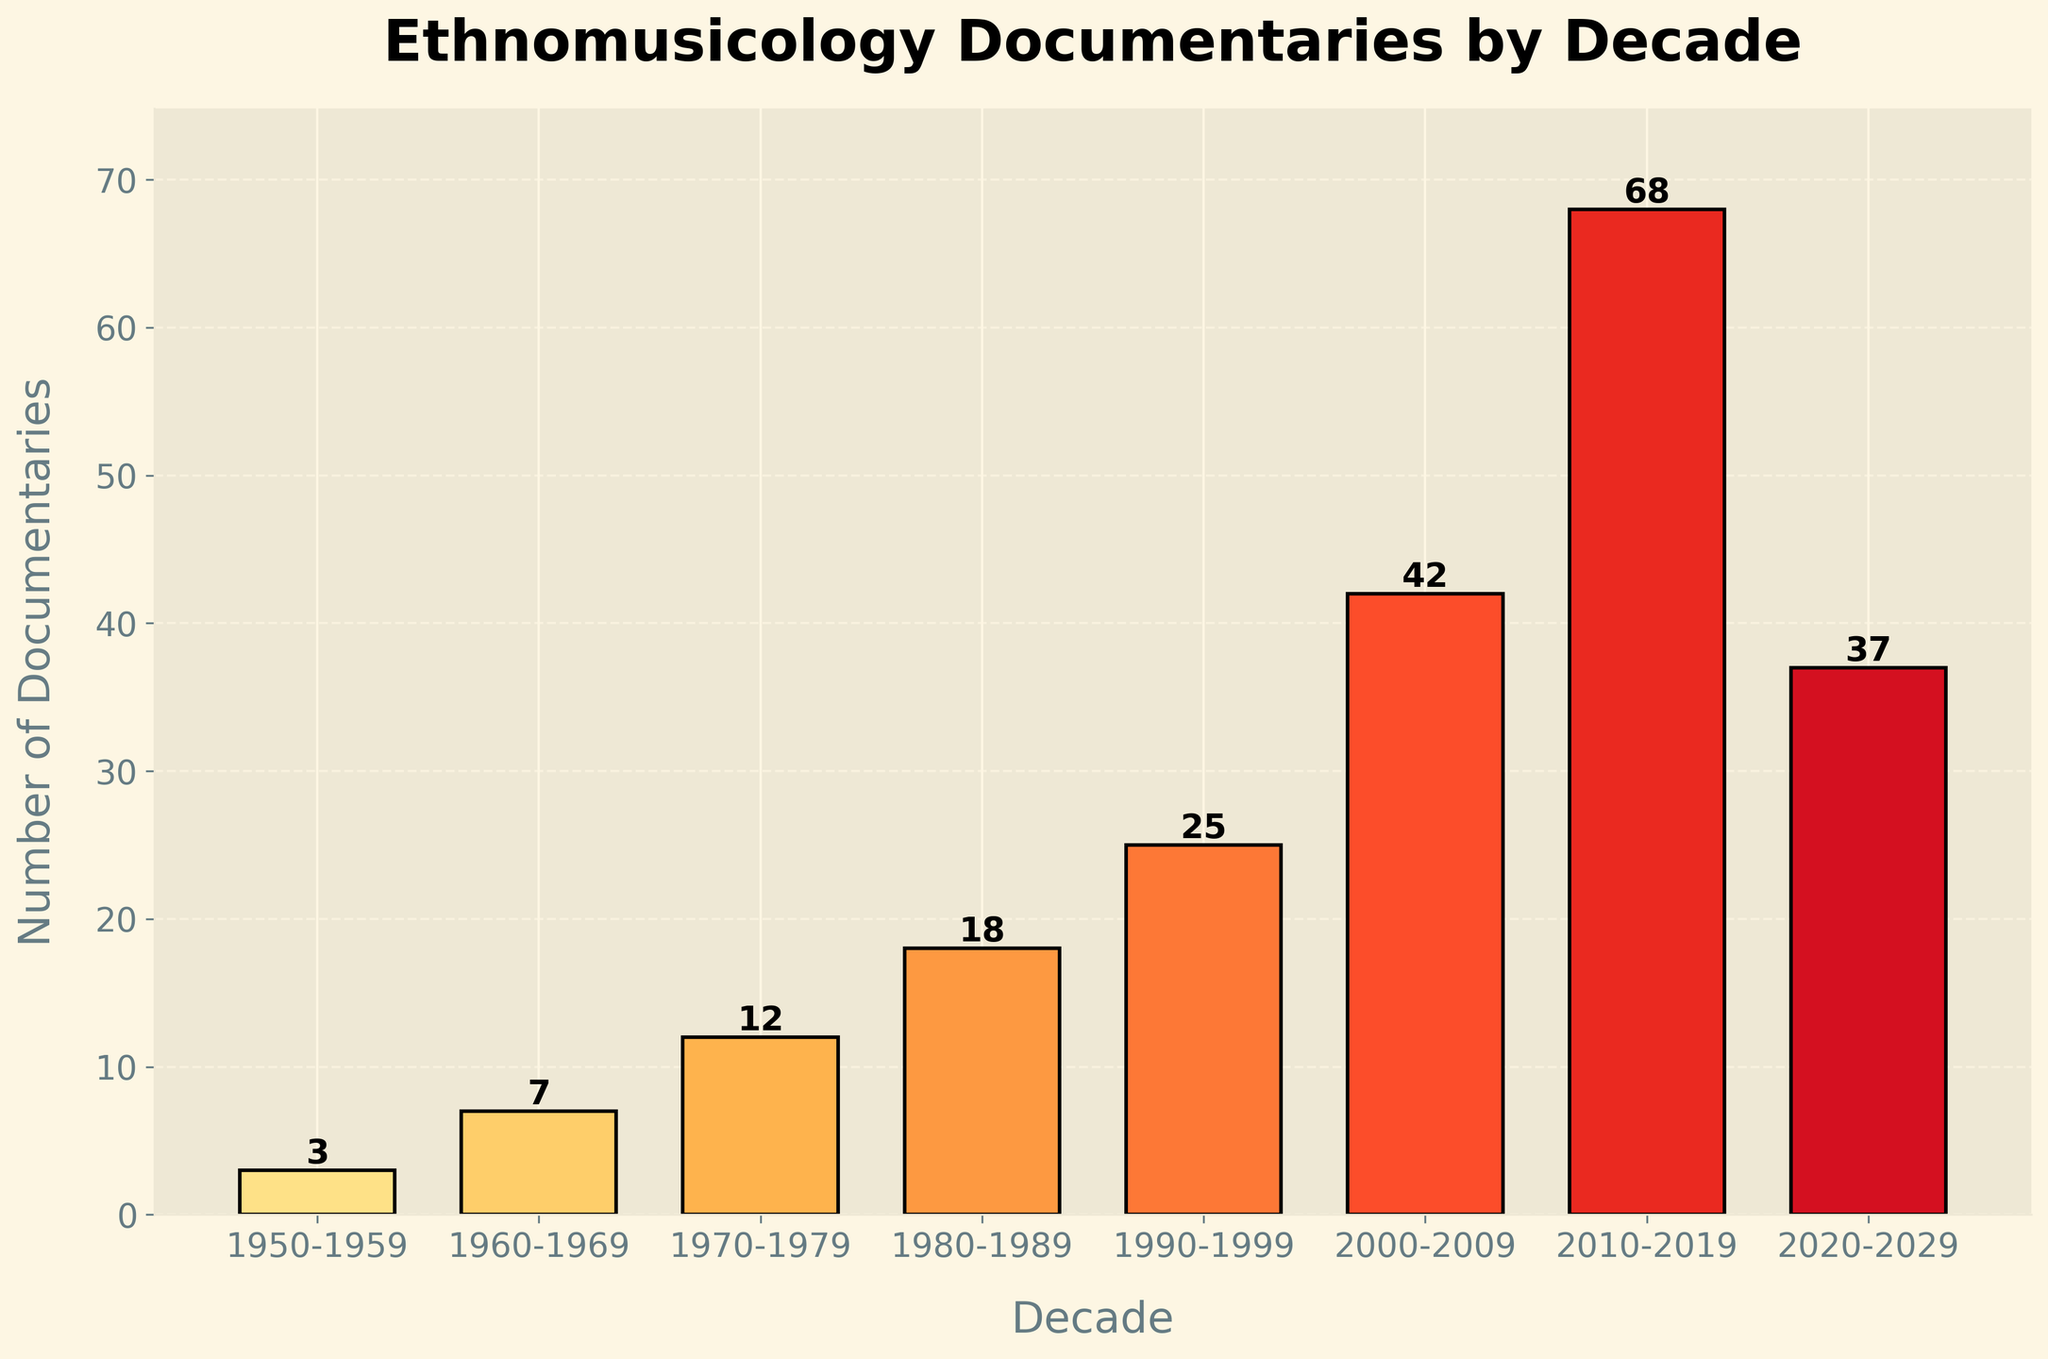How many documentaries were produced between 1970 and 1999? To find the number of documentaries produced between 1970 and 1999, add the values for the decades 1970-1979, 1980-1989, and 1990-1999. This gives 12 (1970-1979) + 18 (1980-1989) + 25 (1990-1999) = 55.
Answer: 55 In which decade did the number of documentaries peak? Look at the bar heights or the numbers labeled on top of each bar. The tallest bar corresponds to the decade 2010-2019 with 68 documentaries.
Answer: 2010-2019 What is the difference in the number of documentaries produced between 2000-2009 and 2020-2029? Subtract the number of documentaries in 2020-2029 from those in 2000-2009. This results in 42 (2000-2009) - 37 (2020-2029) = 5.
Answer: 5 Which decades saw an increase in the number of documentaries produced compared to the previous decade? Compare each bar to the one immediately prior. Increases are observed in decades 1960-1969 (7 > 3), 1970-1979 (12 > 7), 1980-1989 (18 > 12), 1990-1999 (25 > 18), 2000-2009 (42 > 25), and 2010-2019 (68 > 42).
Answer: 1960-1969, 1970-1979, 1980-1989, 1990-1999, 2000-2009, 2010-2019 In which decade was the number of documentaries exactly double the amount from the previous decade? Identify decades where the number of documentaries is double the previous one by comparing each pair: 1960-1969 (7 is not double 3), 1970-1979 (12 is not double 7), 1980-1989 (18 is not double 12), 1990-1999 (25 is not double 18), 2000-2009 (42 is almost double 25), 2010-2019 (68 is not double 42). The closest case is 2000-2009.
Answer: 2000-2009 What is the total number of documentaries produced from 1950-2029? Add the number of documentaries produced each decade: 3 (1950-1959) + 7 (1960-1969) + 12 (1970-1979) + 18 (1980-1989) + 25 (1990-1999) + 42 (2000-2009) + 68 (2010-2019) + 37 (2020-2029) = 212.
Answer: 212 How does the number of documentaries produced in the 1980-1989 decade compare to the 1970-1979 decade? Subtract the number of documentaries in 1970-1979 from those in 1980-1989. This results in 18 (1980-1989) - 12 (1970-1979) = 6 more documentaries in 1980-1989.
Answer: 6 more in 1980-1989 Which decade had the smallest number of documentaries? Look at the heights of the bars to find the shortest one, which corresponds to the decade 1950-1959 with 3 documentaries.
Answer: 1950-1959 What was the growth rate of documentaries between 1990-1999 and 2000-2009? Calculate the growth rate using (Documentaries in 2000-2009 - Documentaries in 1990-1999) / Documentaries in 1990-1999. This gives (42 - 25) / 25 = 17 / 25 = 0.68, or 68%.
Answer: 68% 